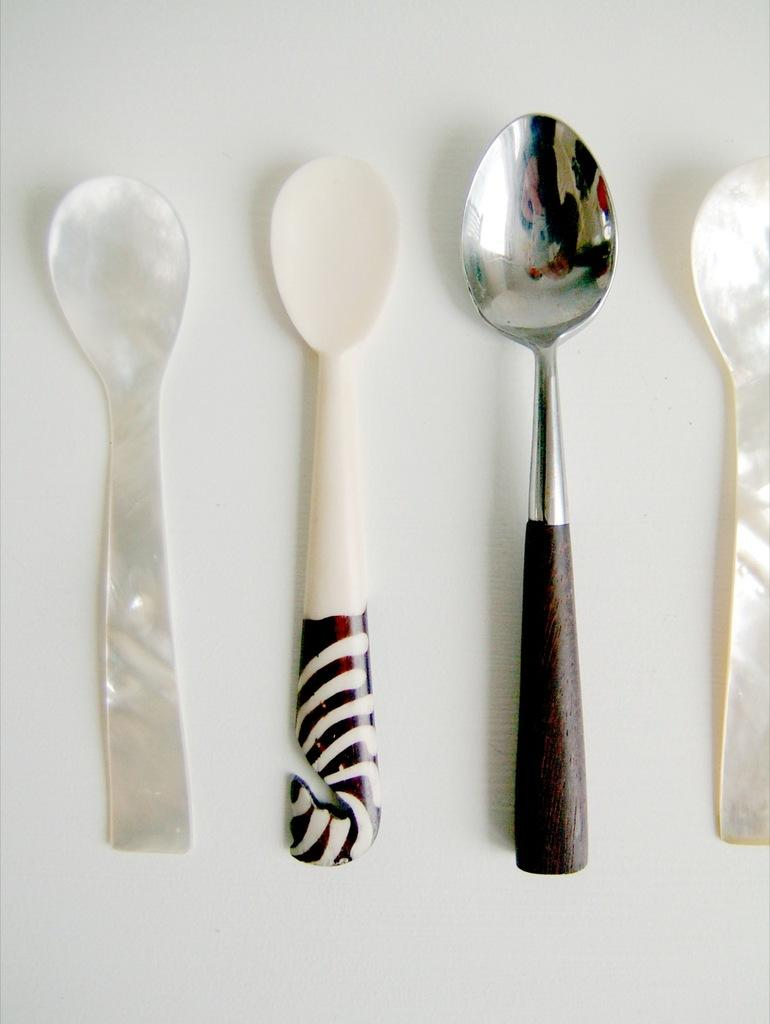How many spoons are visible in the image? There are four spoons in the image. What materials are the spoons made of? One spoon is plastic, one is glass, and one is steel. What is the color of the background in the image? The spoons are placed on a white background. What book is the visitor reading in the image? There is no visitor or book present in the image; it only features spoons on a white background. 